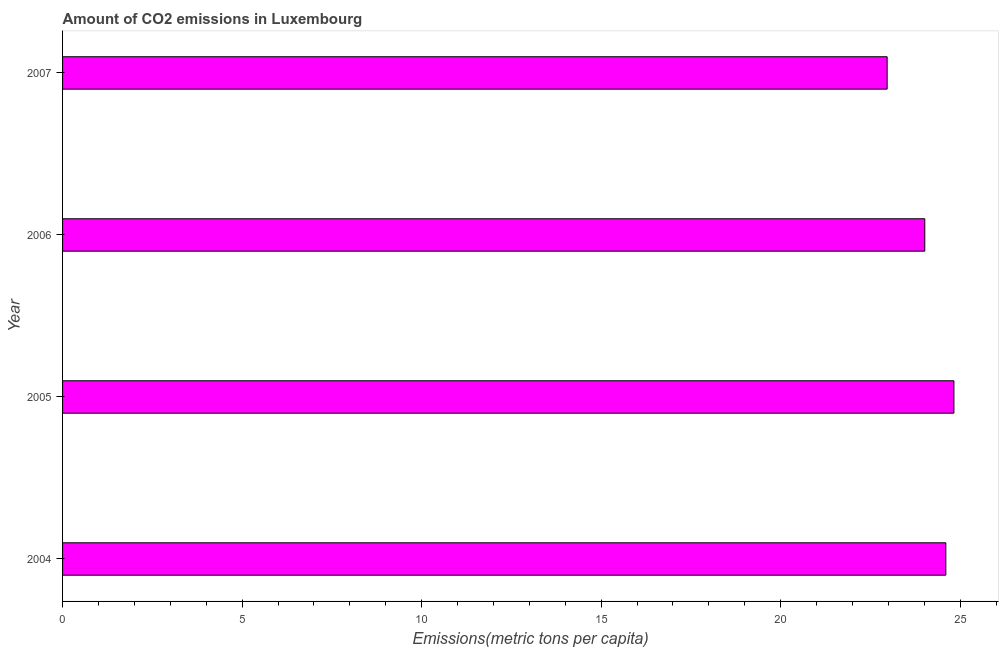Does the graph contain any zero values?
Your response must be concise. No. What is the title of the graph?
Ensure brevity in your answer.  Amount of CO2 emissions in Luxembourg. What is the label or title of the X-axis?
Provide a short and direct response. Emissions(metric tons per capita). What is the label or title of the Y-axis?
Ensure brevity in your answer.  Year. What is the amount of co2 emissions in 2004?
Your answer should be compact. 24.6. Across all years, what is the maximum amount of co2 emissions?
Provide a succinct answer. 24.82. Across all years, what is the minimum amount of co2 emissions?
Keep it short and to the point. 22.96. In which year was the amount of co2 emissions minimum?
Offer a very short reply. 2007. What is the sum of the amount of co2 emissions?
Give a very brief answer. 96.4. What is the difference between the amount of co2 emissions in 2005 and 2006?
Ensure brevity in your answer.  0.81. What is the average amount of co2 emissions per year?
Ensure brevity in your answer.  24.1. What is the median amount of co2 emissions?
Your response must be concise. 24.31. What is the ratio of the amount of co2 emissions in 2004 to that in 2006?
Make the answer very short. 1.02. Is the amount of co2 emissions in 2004 less than that in 2005?
Provide a short and direct response. Yes. Is the difference between the amount of co2 emissions in 2006 and 2007 greater than the difference between any two years?
Make the answer very short. No. What is the difference between the highest and the second highest amount of co2 emissions?
Offer a terse response. 0.23. What is the difference between the highest and the lowest amount of co2 emissions?
Offer a terse response. 1.86. How many bars are there?
Provide a succinct answer. 4. Are all the bars in the graph horizontal?
Your answer should be very brief. Yes. What is the Emissions(metric tons per capita) in 2004?
Provide a succinct answer. 24.6. What is the Emissions(metric tons per capita) of 2005?
Your response must be concise. 24.82. What is the Emissions(metric tons per capita) in 2006?
Offer a very short reply. 24.01. What is the Emissions(metric tons per capita) of 2007?
Offer a very short reply. 22.96. What is the difference between the Emissions(metric tons per capita) in 2004 and 2005?
Keep it short and to the point. -0.23. What is the difference between the Emissions(metric tons per capita) in 2004 and 2006?
Offer a very short reply. 0.59. What is the difference between the Emissions(metric tons per capita) in 2004 and 2007?
Give a very brief answer. 1.63. What is the difference between the Emissions(metric tons per capita) in 2005 and 2006?
Give a very brief answer. 0.81. What is the difference between the Emissions(metric tons per capita) in 2005 and 2007?
Make the answer very short. 1.86. What is the difference between the Emissions(metric tons per capita) in 2006 and 2007?
Your answer should be very brief. 1.05. What is the ratio of the Emissions(metric tons per capita) in 2004 to that in 2006?
Provide a succinct answer. 1.02. What is the ratio of the Emissions(metric tons per capita) in 2004 to that in 2007?
Give a very brief answer. 1.07. What is the ratio of the Emissions(metric tons per capita) in 2005 to that in 2006?
Provide a short and direct response. 1.03. What is the ratio of the Emissions(metric tons per capita) in 2005 to that in 2007?
Ensure brevity in your answer.  1.08. What is the ratio of the Emissions(metric tons per capita) in 2006 to that in 2007?
Offer a terse response. 1.05. 